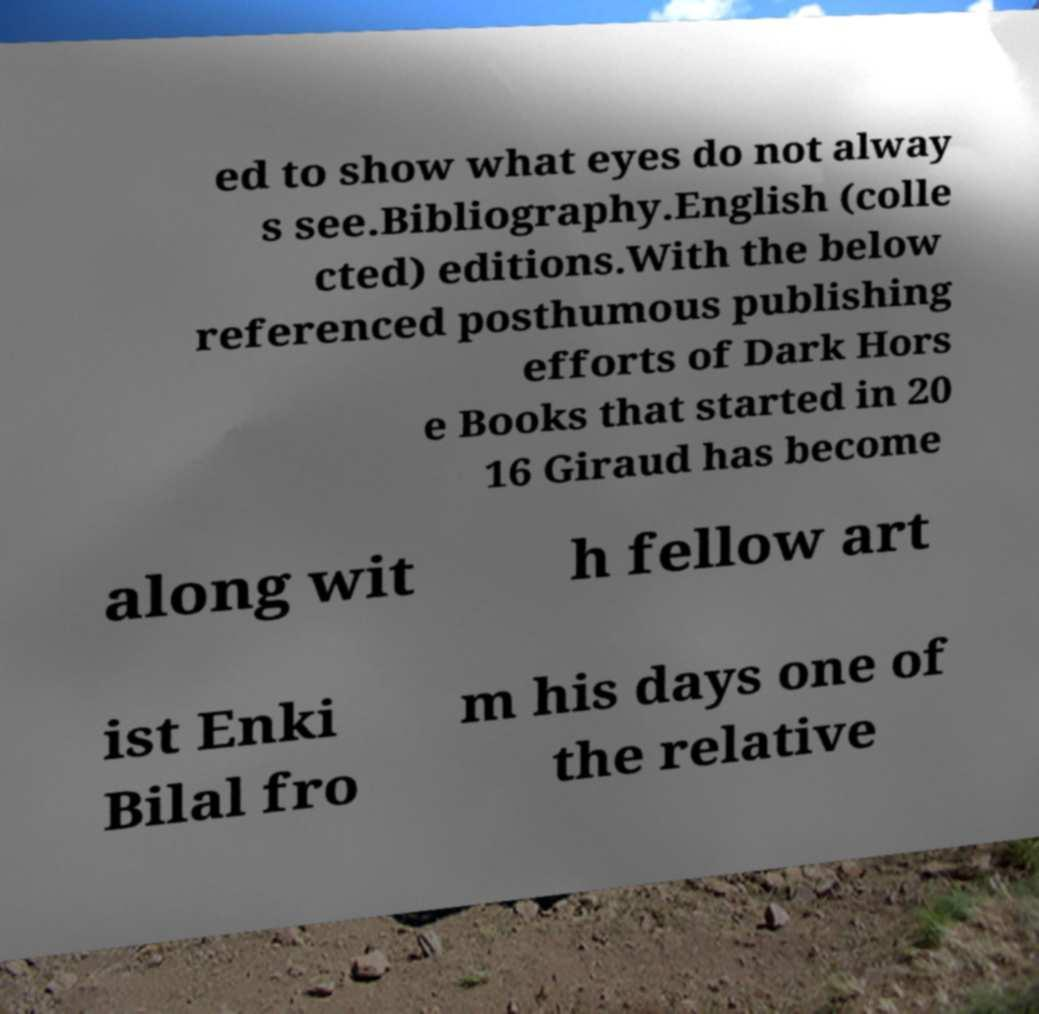Can you accurately transcribe the text from the provided image for me? ed to show what eyes do not alway s see.Bibliography.English (colle cted) editions.With the below referenced posthumous publishing efforts of Dark Hors e Books that started in 20 16 Giraud has become along wit h fellow art ist Enki Bilal fro m his days one of the relative 